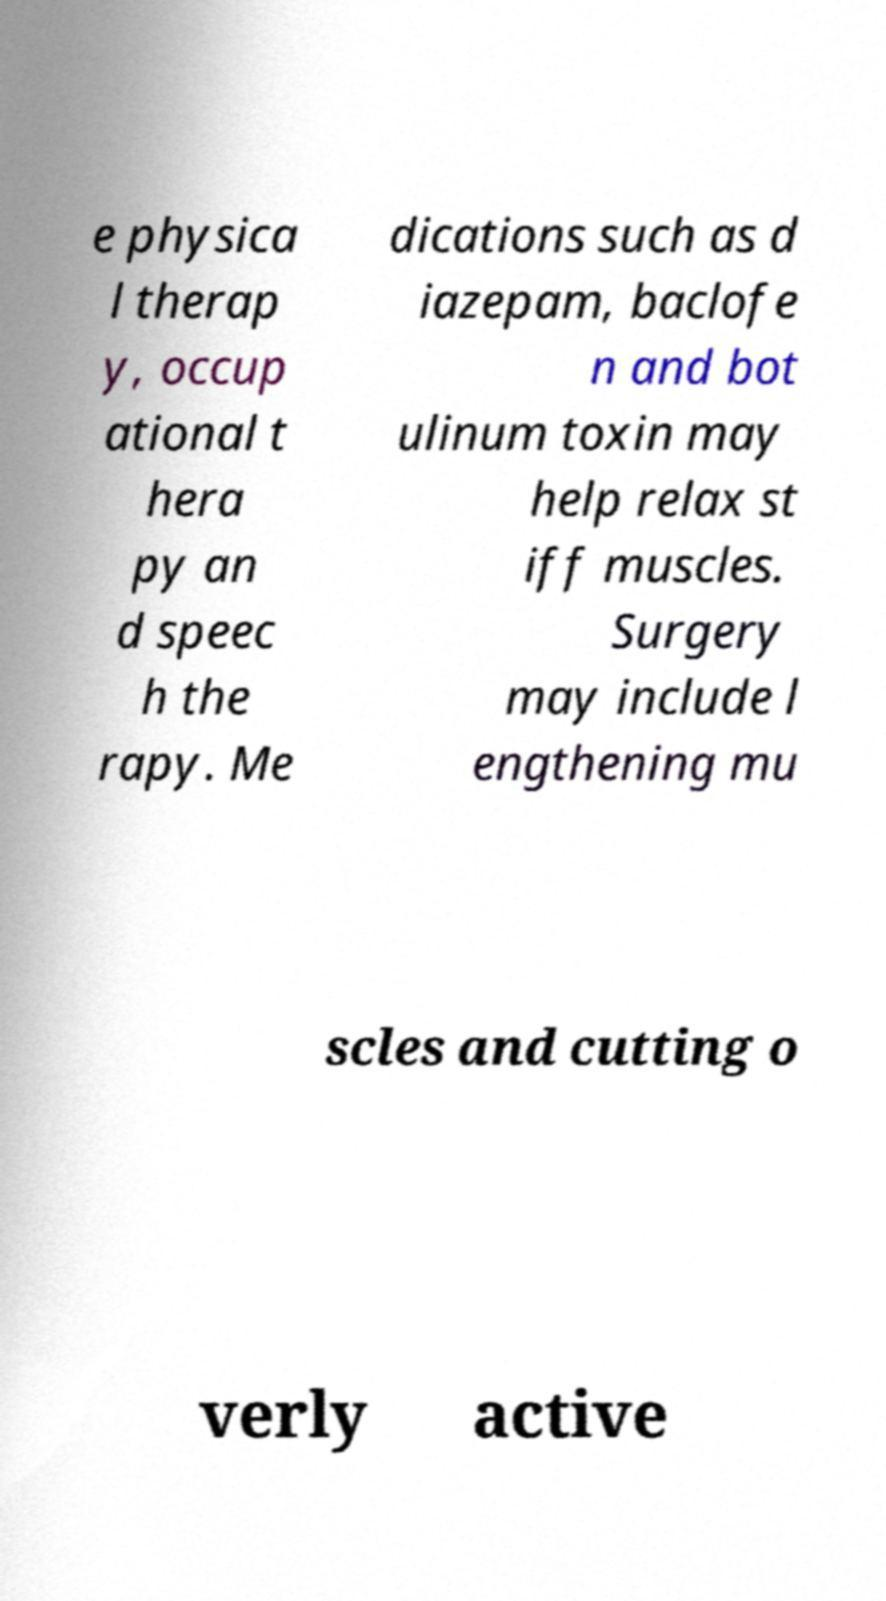I need the written content from this picture converted into text. Can you do that? e physica l therap y, occup ational t hera py an d speec h the rapy. Me dications such as d iazepam, baclofe n and bot ulinum toxin may help relax st iff muscles. Surgery may include l engthening mu scles and cutting o verly active 